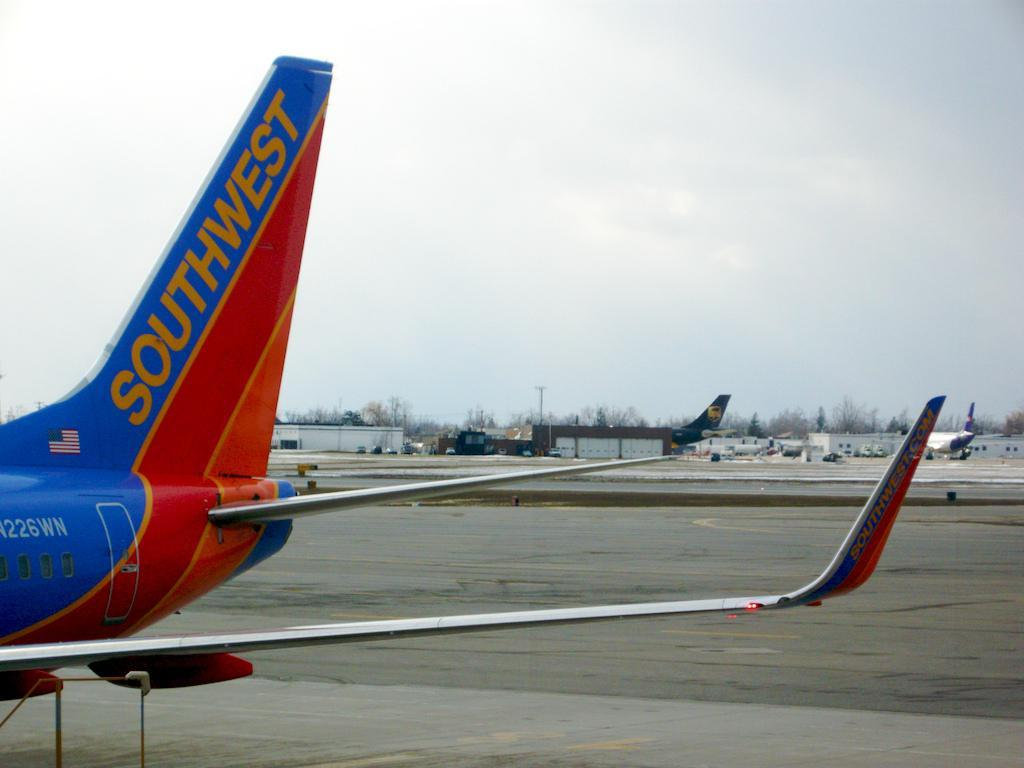<image>
Relay a brief, clear account of the picture shown. A Southwest commercial jet is parked at an airport. 